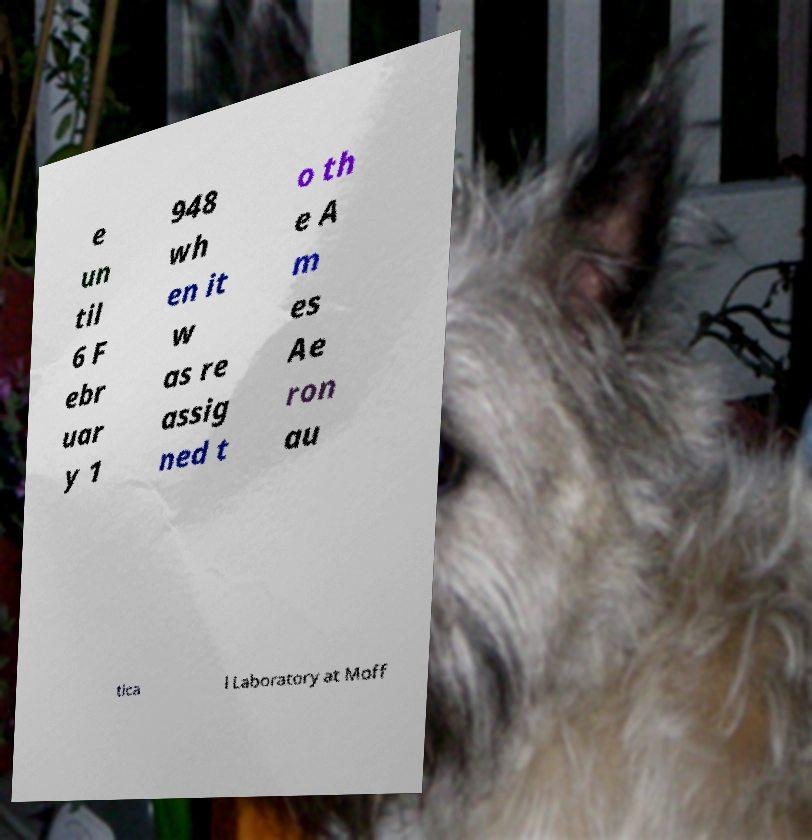Can you accurately transcribe the text from the provided image for me? e un til 6 F ebr uar y 1 948 wh en it w as re assig ned t o th e A m es Ae ron au tica l Laboratory at Moff 